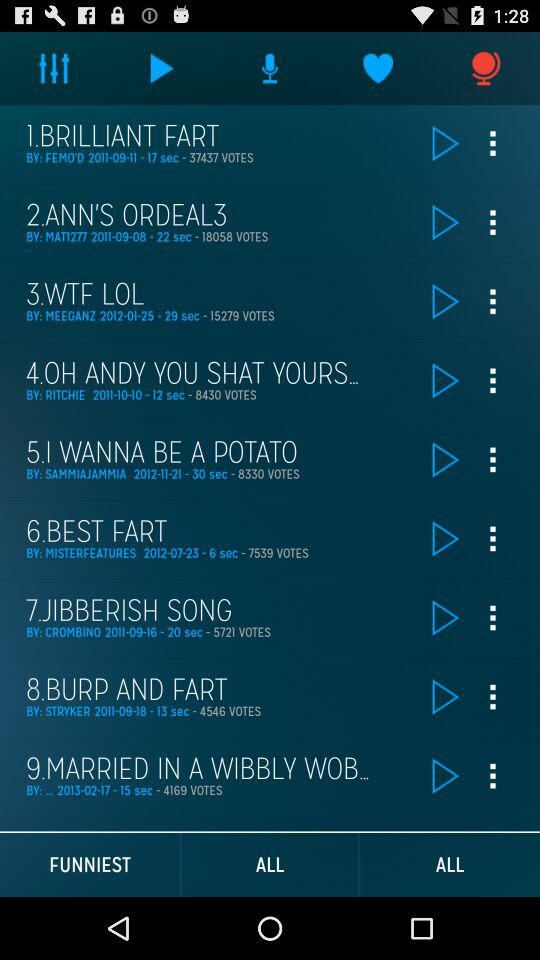What is the mentioned date of the brilliant fart? The date is 2011-09-11. 